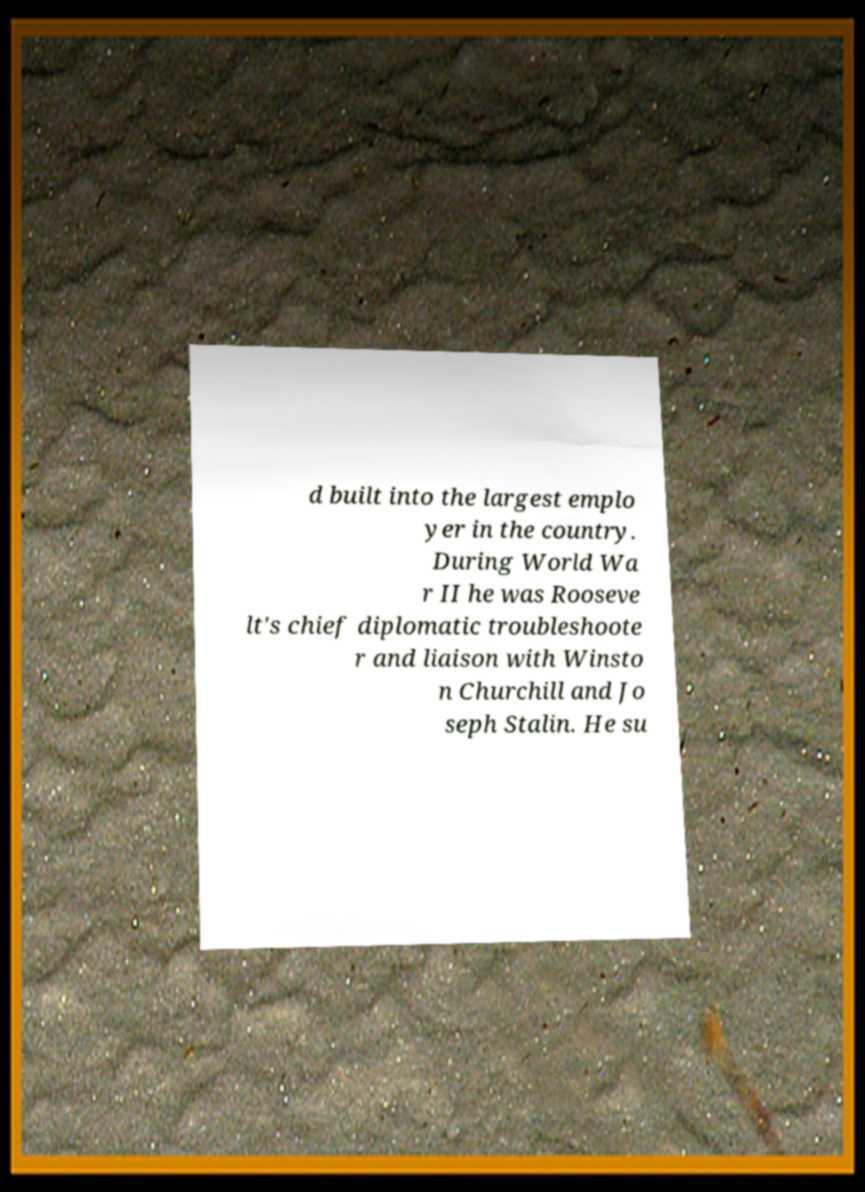I need the written content from this picture converted into text. Can you do that? d built into the largest emplo yer in the country. During World Wa r II he was Rooseve lt's chief diplomatic troubleshoote r and liaison with Winsto n Churchill and Jo seph Stalin. He su 